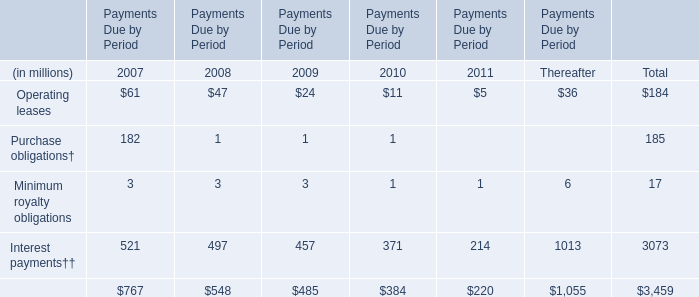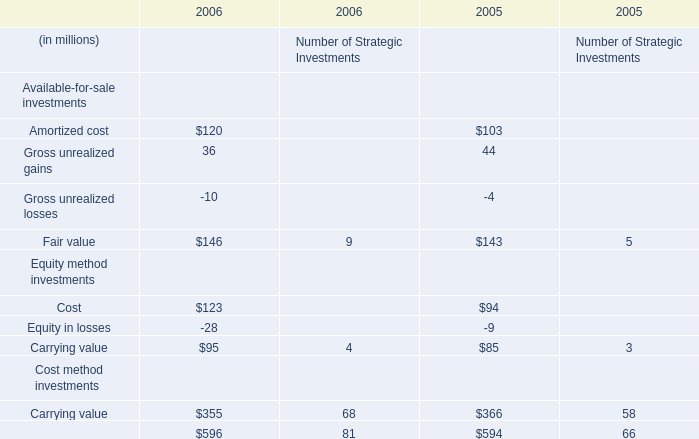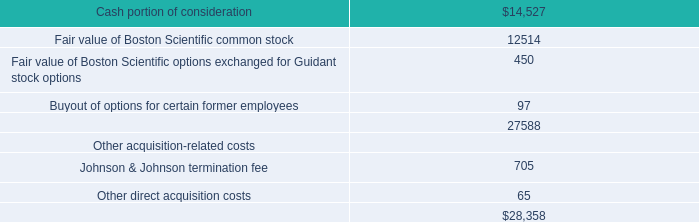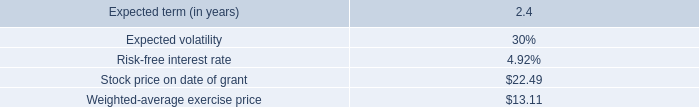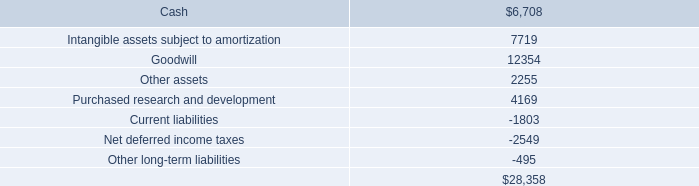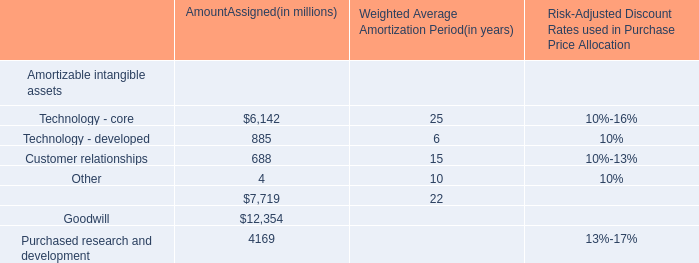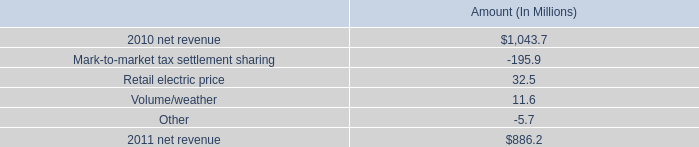what is change in percentage points in net income margin in 2011? 
Computations: (242.5 / 886.2)
Answer: 0.27364. 